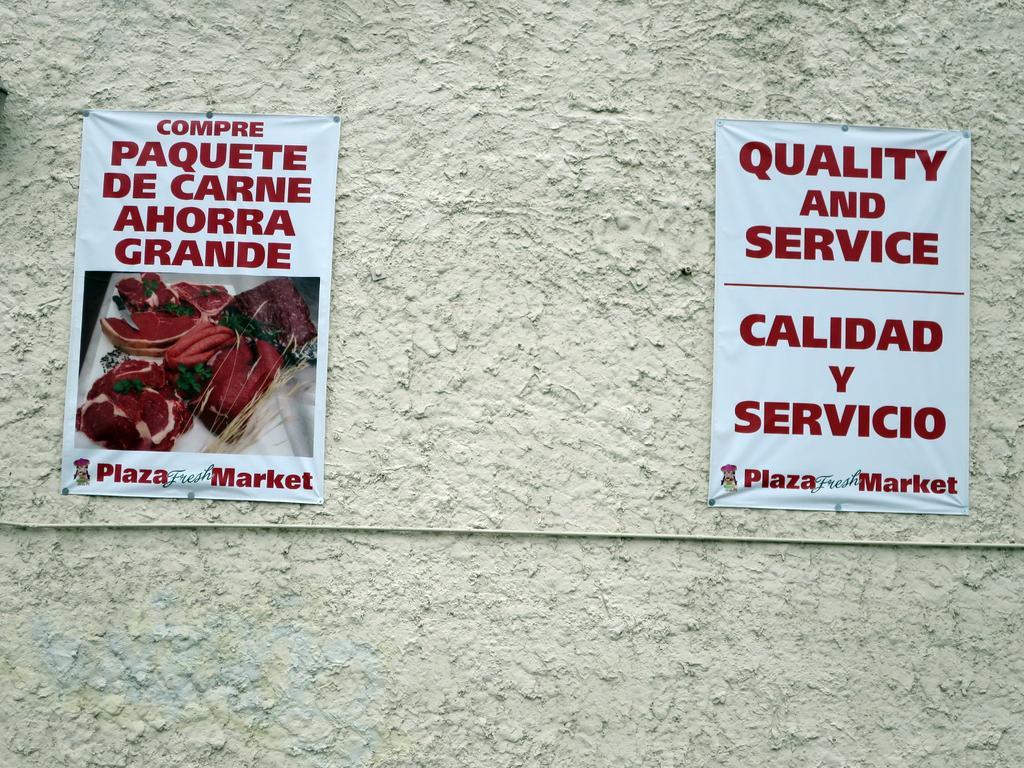In one or two sentences, can you explain what this image depicts? In this image we can see two posts attached to the wall and on one poster we can see the image and also the text and on another poster there is text. 